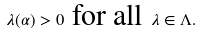<formula> <loc_0><loc_0><loc_500><loc_500>\lambda ( \alpha ) > 0 \text { for all } \lambda \in \Lambda .</formula> 